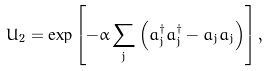<formula> <loc_0><loc_0><loc_500><loc_500>U _ { 2 } = \exp \left [ - \alpha \sum _ { j } \left ( a ^ { \dagger } _ { j } a ^ { \dagger } _ { j } - a _ { j } a _ { j } \right ) \right ] ,</formula> 